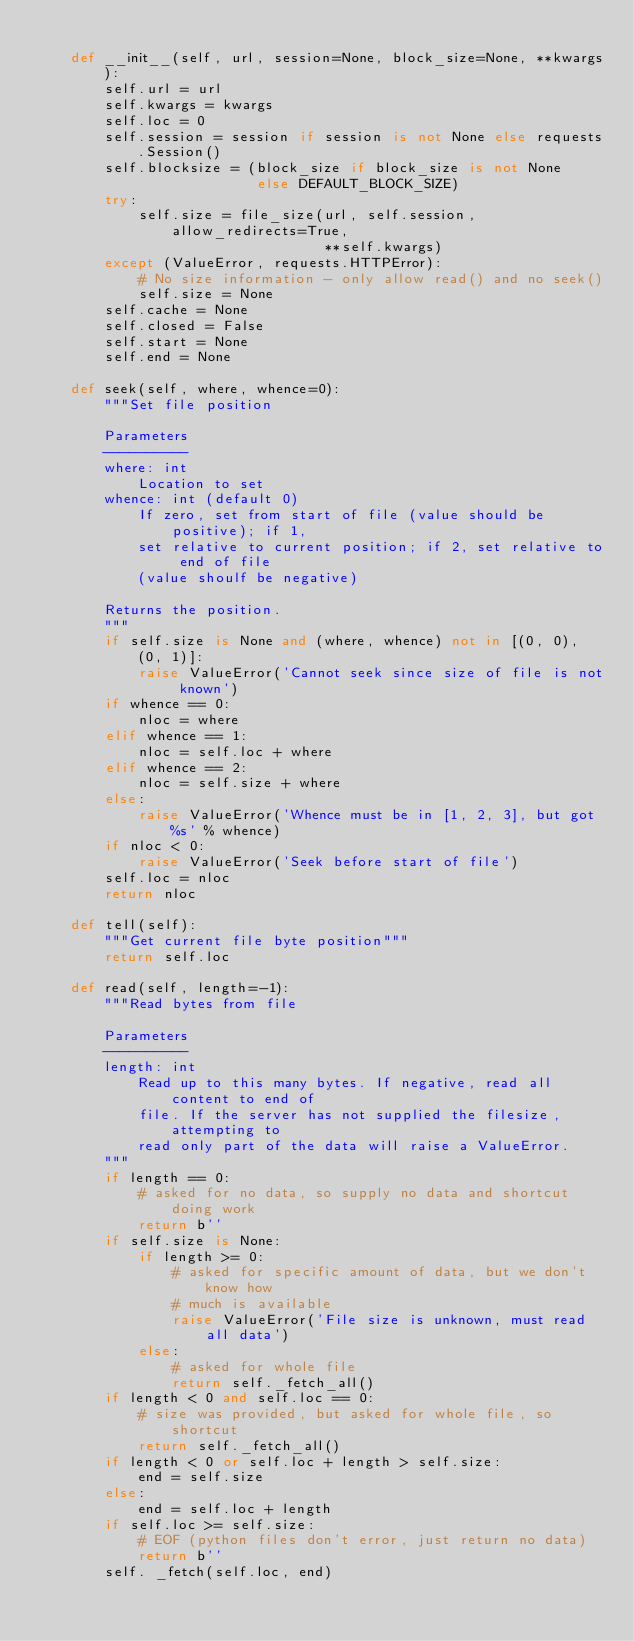<code> <loc_0><loc_0><loc_500><loc_500><_Python_>
    def __init__(self, url, session=None, block_size=None, **kwargs):
        self.url = url
        self.kwargs = kwargs
        self.loc = 0
        self.session = session if session is not None else requests.Session()
        self.blocksize = (block_size if block_size is not None
                          else DEFAULT_BLOCK_SIZE)
        try:
            self.size = file_size(url, self.session, allow_redirects=True,
                                  **self.kwargs)
        except (ValueError, requests.HTTPError):
            # No size information - only allow read() and no seek()
            self.size = None
        self.cache = None
        self.closed = False
        self.start = None
        self.end = None

    def seek(self, where, whence=0):
        """Set file position

        Parameters
        ----------
        where: int
            Location to set
        whence: int (default 0)
            If zero, set from start of file (value should be positive); if 1,
            set relative to current position; if 2, set relative to end of file
            (value shoulf be negative)

        Returns the position.
        """
        if self.size is None and (where, whence) not in [(0, 0), (0, 1)]:
            raise ValueError('Cannot seek since size of file is not known')
        if whence == 0:
            nloc = where
        elif whence == 1:
            nloc = self.loc + where
        elif whence == 2:
            nloc = self.size + where
        else:
            raise ValueError('Whence must be in [1, 2, 3], but got %s' % whence)
        if nloc < 0:
            raise ValueError('Seek before start of file')
        self.loc = nloc
        return nloc

    def tell(self):
        """Get current file byte position"""
        return self.loc

    def read(self, length=-1):
        """Read bytes from file

        Parameters
        ----------
        length: int
            Read up to this many bytes. If negative, read all content to end of
            file. If the server has not supplied the filesize, attempting to
            read only part of the data will raise a ValueError.
        """
        if length == 0:
            # asked for no data, so supply no data and shortcut doing work
            return b''
        if self.size is None:
            if length >= 0:
                # asked for specific amount of data, but we don't know how
                # much is available
                raise ValueError('File size is unknown, must read all data')
            else:
                # asked for whole file
                return self._fetch_all()
        if length < 0 and self.loc == 0:
            # size was provided, but asked for whole file, so shortcut
            return self._fetch_all()
        if length < 0 or self.loc + length > self.size:
            end = self.size
        else:
            end = self.loc + length
        if self.loc >= self.size:
            # EOF (python files don't error, just return no data)
            return b''
        self. _fetch(self.loc, end)</code> 